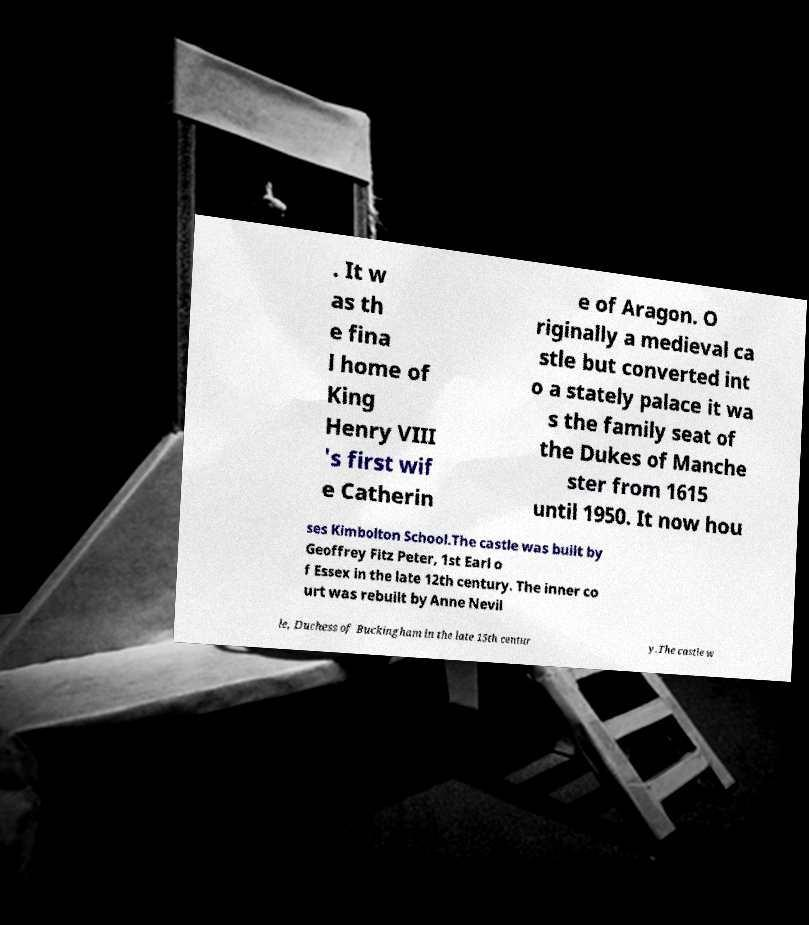Could you extract and type out the text from this image? . It w as th e fina l home of King Henry VIII 's first wif e Catherin e of Aragon. O riginally a medieval ca stle but converted int o a stately palace it wa s the family seat of the Dukes of Manche ster from 1615 until 1950. It now hou ses Kimbolton School.The castle was built by Geoffrey Fitz Peter, 1st Earl o f Essex in the late 12th century. The inner co urt was rebuilt by Anne Nevil le, Duchess of Buckingham in the late 15th centur y.The castle w 